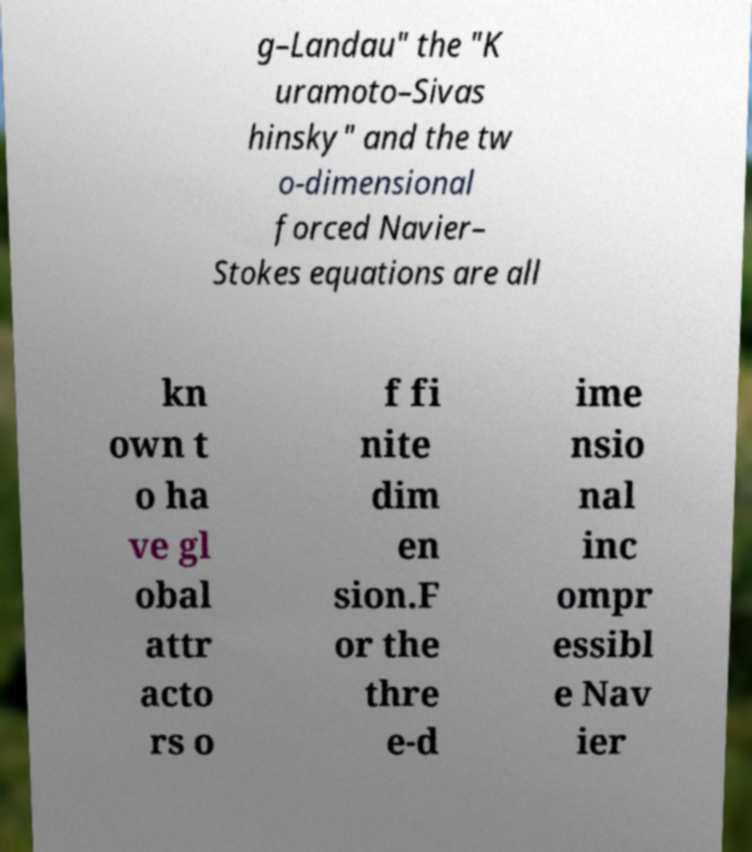I need the written content from this picture converted into text. Can you do that? g–Landau" the "K uramoto–Sivas hinsky" and the tw o-dimensional forced Navier– Stokes equations are all kn own t o ha ve gl obal attr acto rs o f fi nite dim en sion.F or the thre e-d ime nsio nal inc ompr essibl e Nav ier 